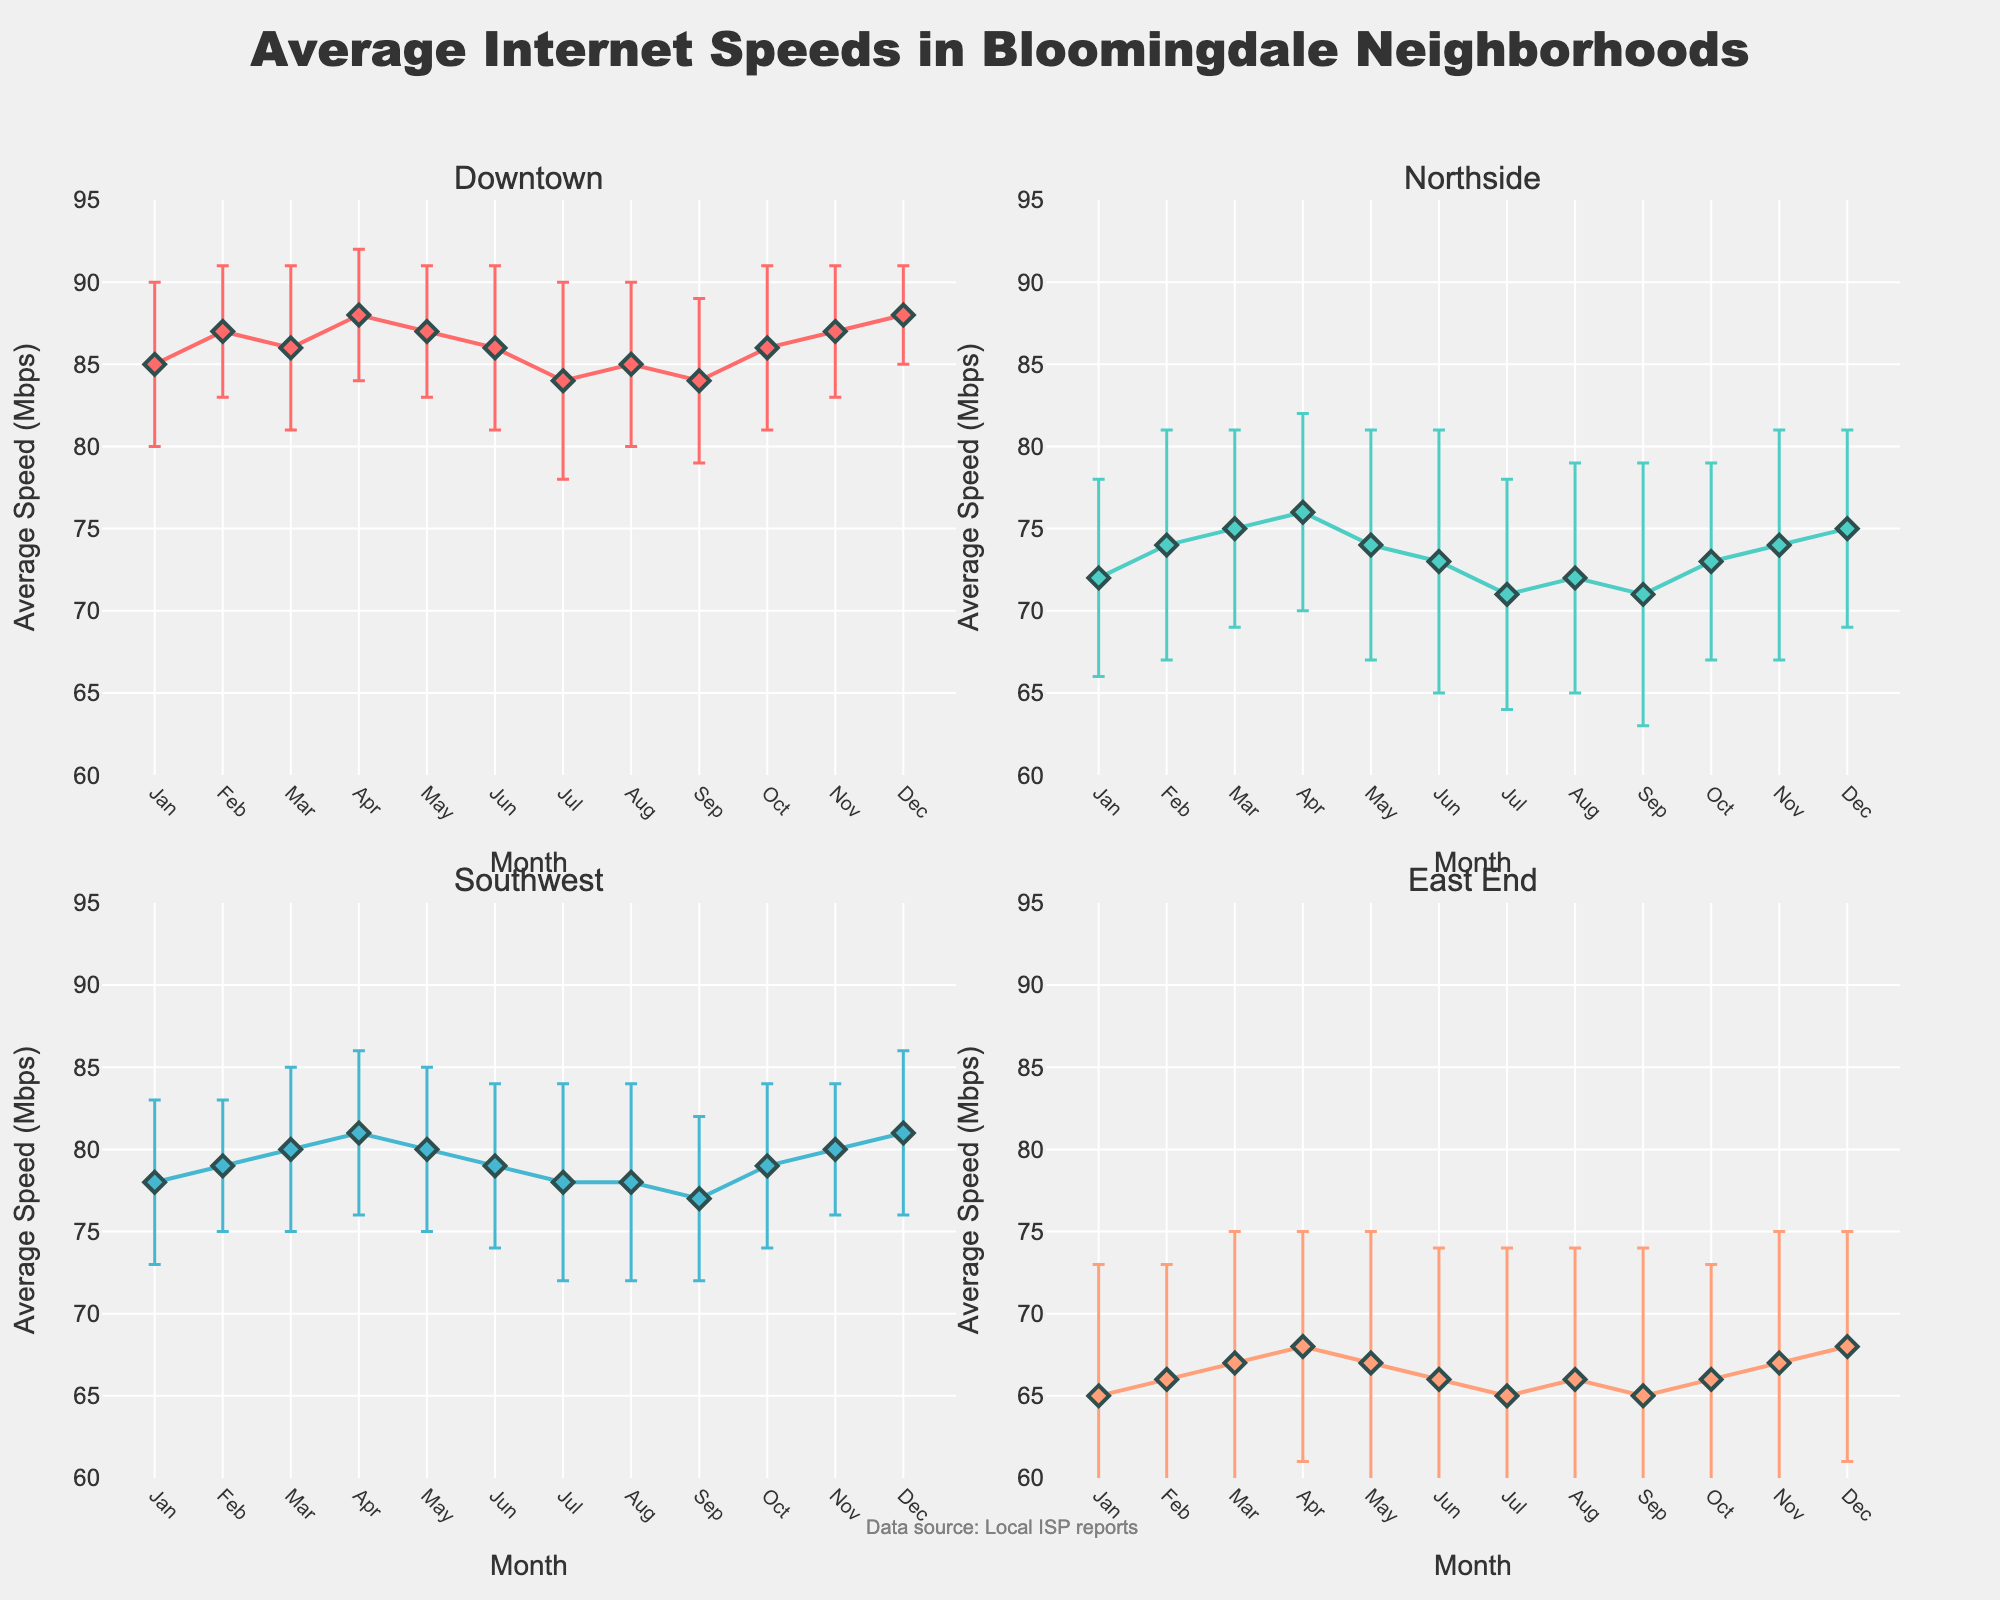What's the title of the plot? The title is positioned at the top of the figure and reads: "Average Internet Speeds in Bloomingdale Neighborhoods".
Answer: Average Internet Speeds in Bloomingdale Neighborhoods Which neighborhood has the highest overall average internet speed? By examining the average speeds across all months for each neighborhood, Downtown maintains the highest values, usually above 84 Mbps, while other neighborhoods have lower average speeds.
Answer: Downtown What month shows the largest variability in internet speed for the East End? The standard deviation, shown by the error bars, is largest in July for the East End, indicating more variability in the measured speeds.
Answer: July How does the average speed in Northside compare with Downtown in June? In June, Northside has an average speed of 73 Mbps whereas Downtown has 86 Mbps, showing that Downtown has a significantly higher speed.
Answer: Downtown has higher speed What is the average of the average internet speeds for Southwest in Q1 (Jan-Mar)? Sum the average speeds (78 + 79 + 80) and divide by the number of months (3) to get the average 79.
Answer: 79 Mbps Which month shows the lowest average speed for Southwest, and what is the value? By scanning through months for Southwest, the month of September shows the lowest average internet speed with 77 Mbps.
Answer: September, 77 Mbps Compare the internet speed variability between Downtown and East End in December. Which one is more variable? Look at the standard deviations (error bars) for both neighborhoods in December. East End has a standard deviation of 7 while Downtown has 3, making East End more variable.
Answer: East End Which two neighborhoods have the same trend in speed fluctuation over the year? By looking at the trends (up and down patterns) throughout the year, Downtown and Southwest both show relatively stable trends with small fluctuations.
Answer: Downtown and Southwest Was there an improvement in average internet speed in Northside from January to December? Compare the average speeds: Northside in January is 72 Mbps and in December is 75 Mbps, indicating a small improvement.
Answer: Yes During which month does Downtown experience its lowest average internet speed? Look for the lowest point on Downtown’s line which is in July with 84 Mbps.
Answer: July 